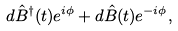Convert formula to latex. <formula><loc_0><loc_0><loc_500><loc_500>d \hat { B } ^ { \dagger } ( t ) e ^ { i \phi } + d \hat { B } ( t ) e ^ { - i \phi } ,</formula> 